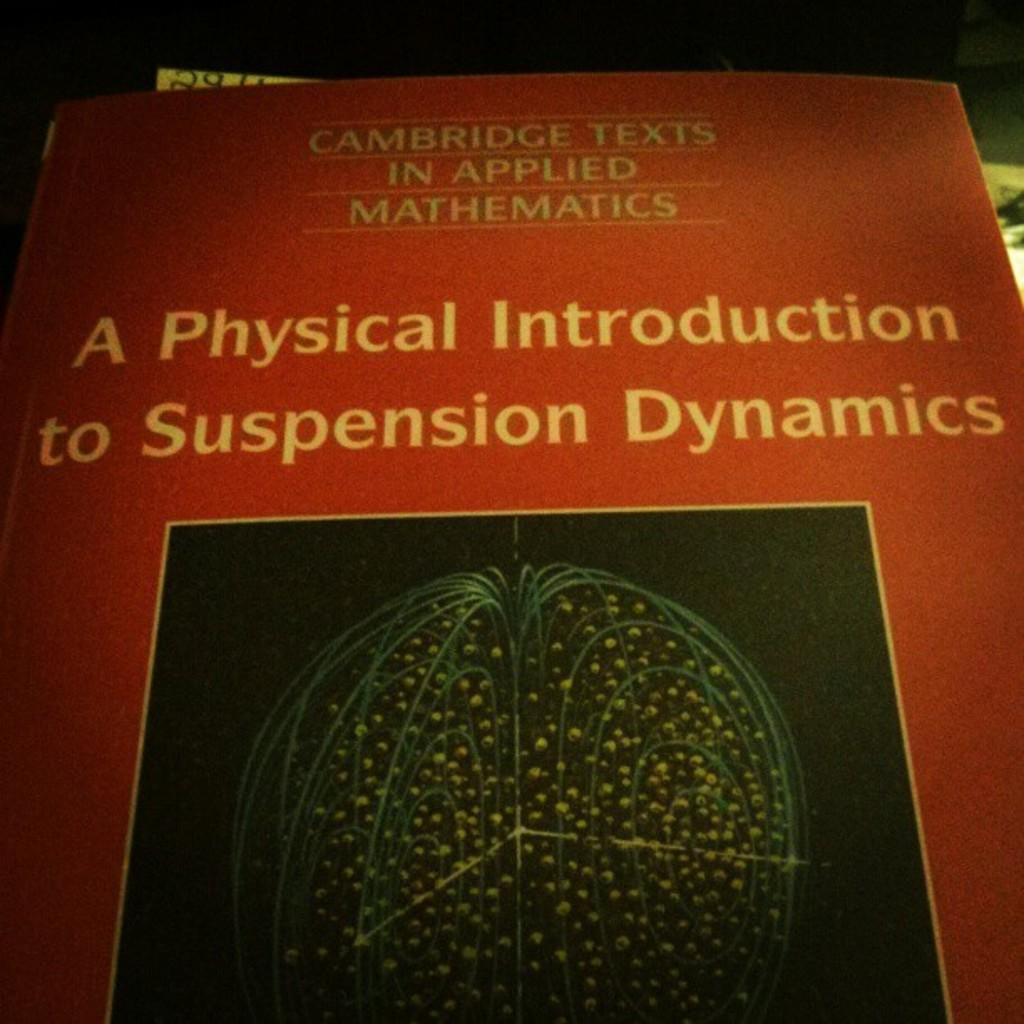This text book is an introduction to what topic?
Provide a succinct answer. Suspension dynamics. Who published this book?
Keep it short and to the point. Cambridge. 